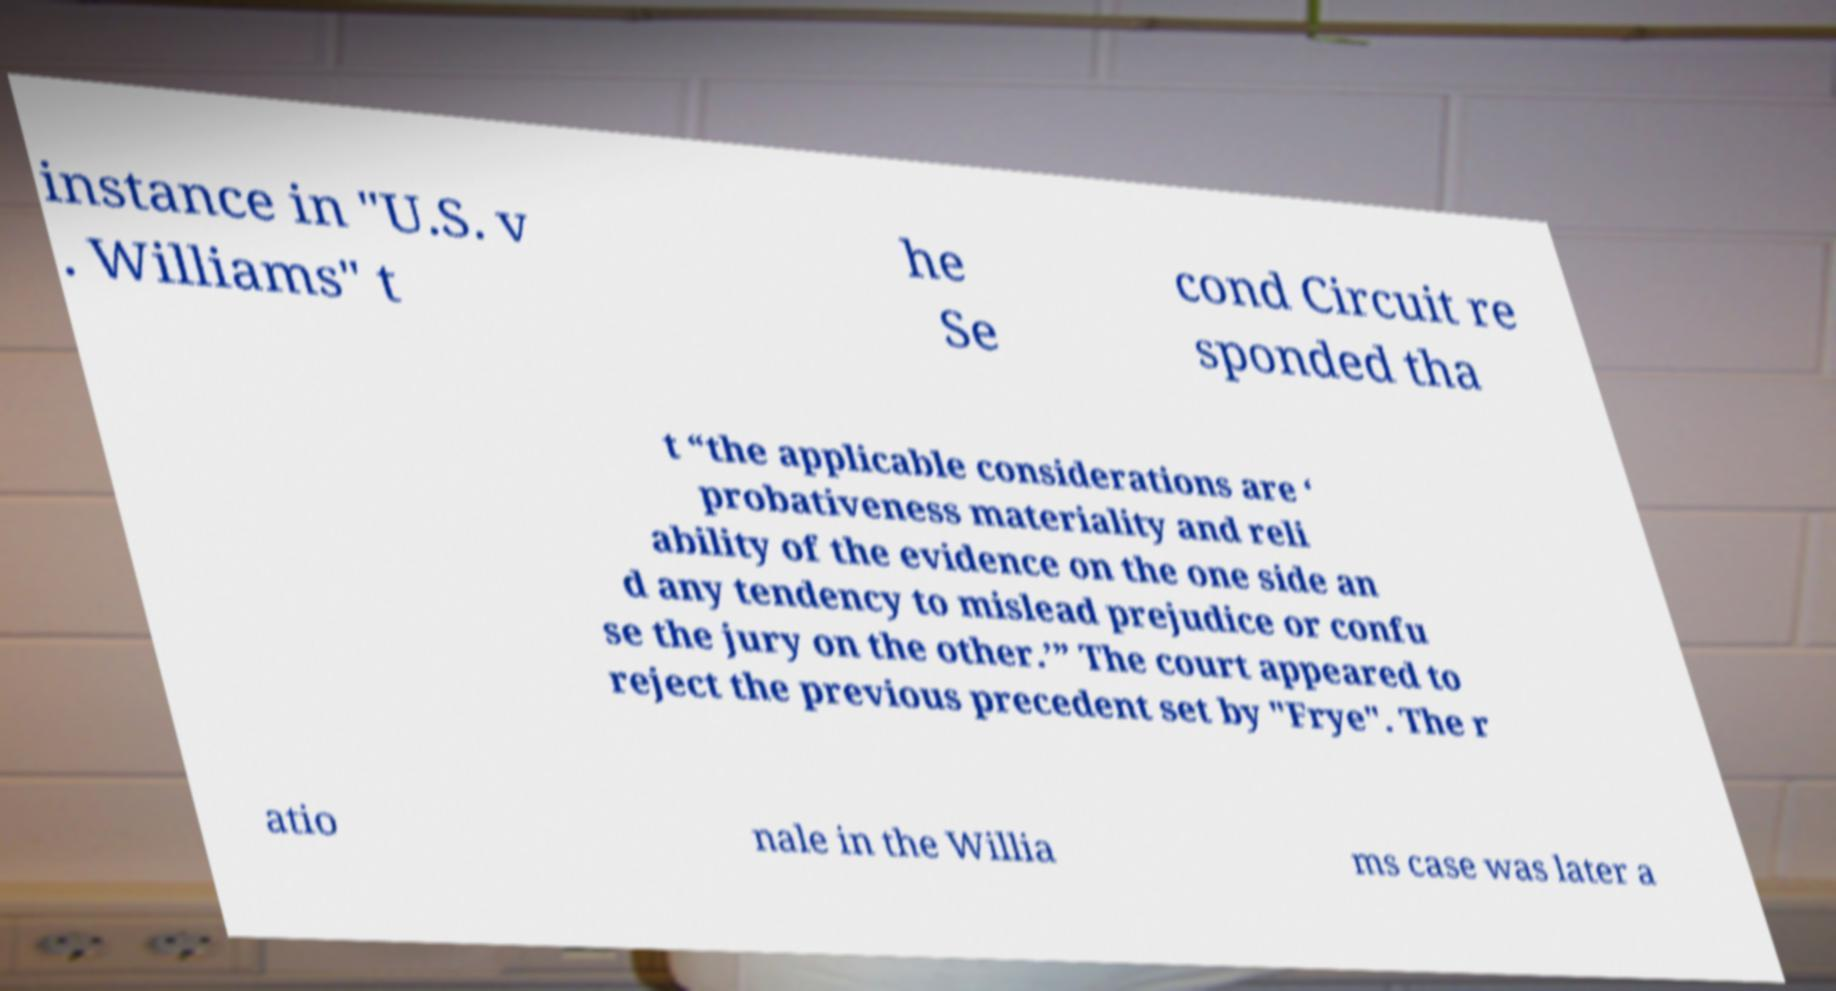What messages or text are displayed in this image? I need them in a readable, typed format. instance in "U.S. v . Williams" t he Se cond Circuit re sponded tha t “the applicable considerations are ‘ probativeness materiality and reli ability of the evidence on the one side an d any tendency to mislead prejudice or confu se the jury on the other.’” The court appeared to reject the previous precedent set by "Frye". The r atio nale in the Willia ms case was later a 